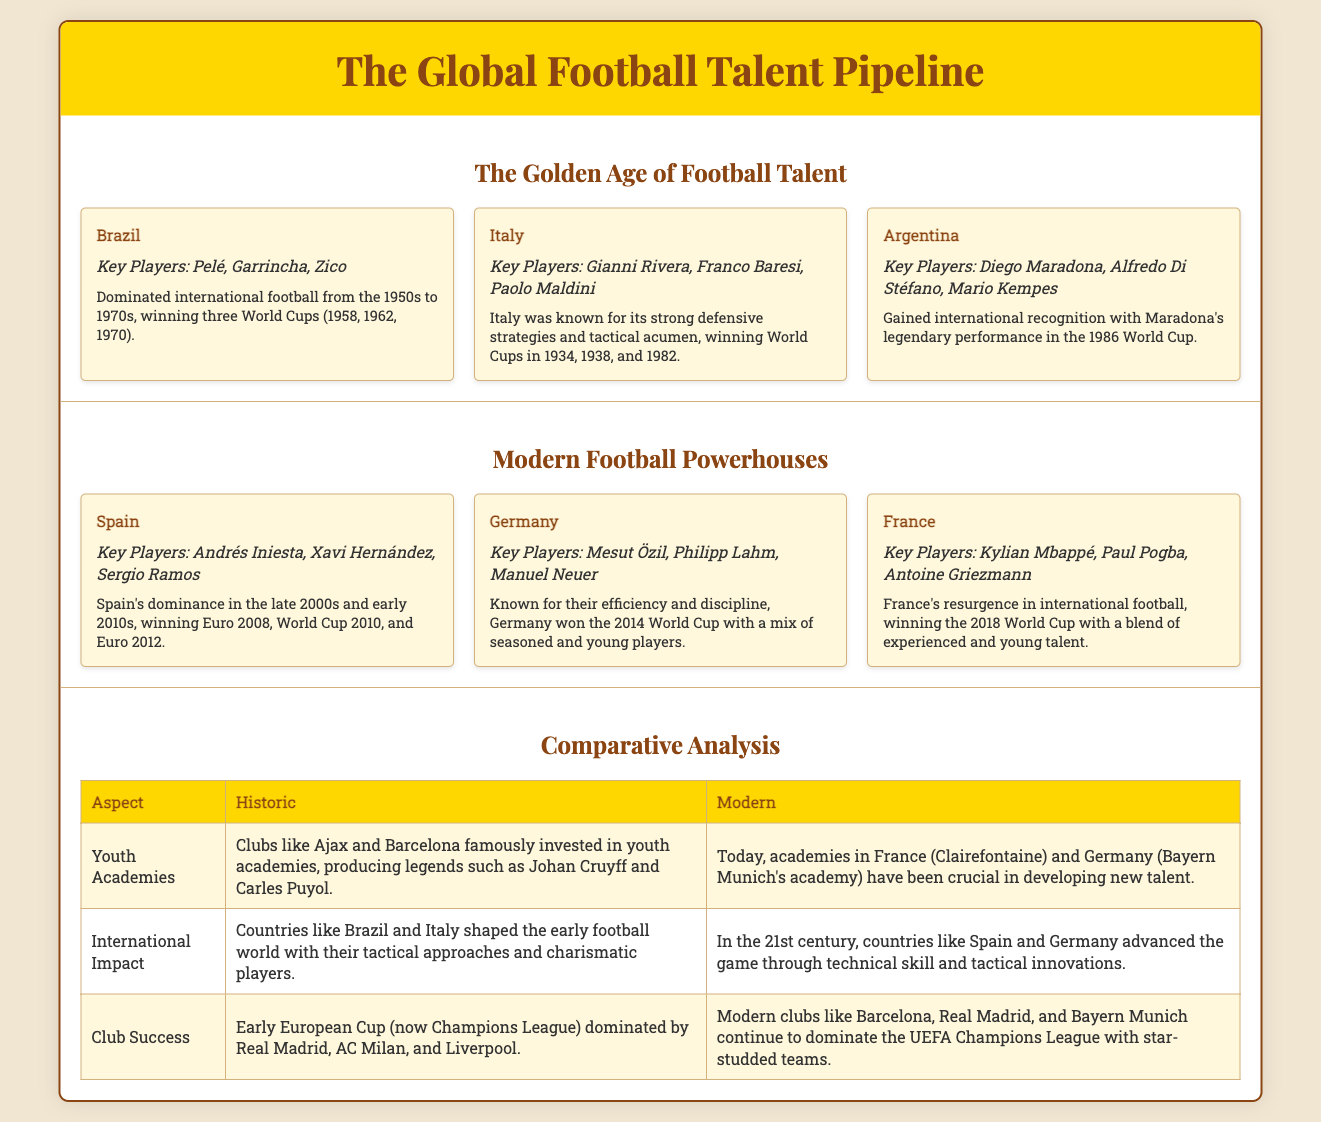What key players are associated with Brazil? Brazil's key players listed in the infographic are Pelé, Garrincha, and Zico.
Answer: Pelé, Garrincha, Zico What year did France win the World Cup? The infographic highlights that France won the World Cup in 2018.
Answer: 2018 What was Italy known for in their football strategy? The document states Italy was known for its strong defensive strategies and tactical acumen.
Answer: Strong defensive strategies Which historic country is credited with producing Johan Cruyff? The document mentions that Ajax, a historic club, famously invested in youth academies producing Johan Cruyff.
Answer: Ajax How many World Cups did Brazil win during the Golden Age? According to the infographic, Brazil won three World Cups during that period.
Answer: Three Which modern country has succeeded with youth academies like Clairefontaine? The document highlights France's Clairefontaine as a modern academy crucial for developing talent.
Answer: France Which nation is recognized for its tactical innovations in modern football? The infographic states that Germany advanced the game through tactical innovations in the 21st century.
Answer: Germany What does the comparison table highlight about early European Cup clubs? The comparison table notes clubs like Real Madrid, AC Milan, and Liverpool dominated the early European Cup.
Answer: Real Madrid, AC Milan, Liverpool What major international recognition did Argentina achieve in 1986? The document highlights Argentina gained international recognition with Maradona's performance in the 1986 World Cup.
Answer: Maradona's performance 